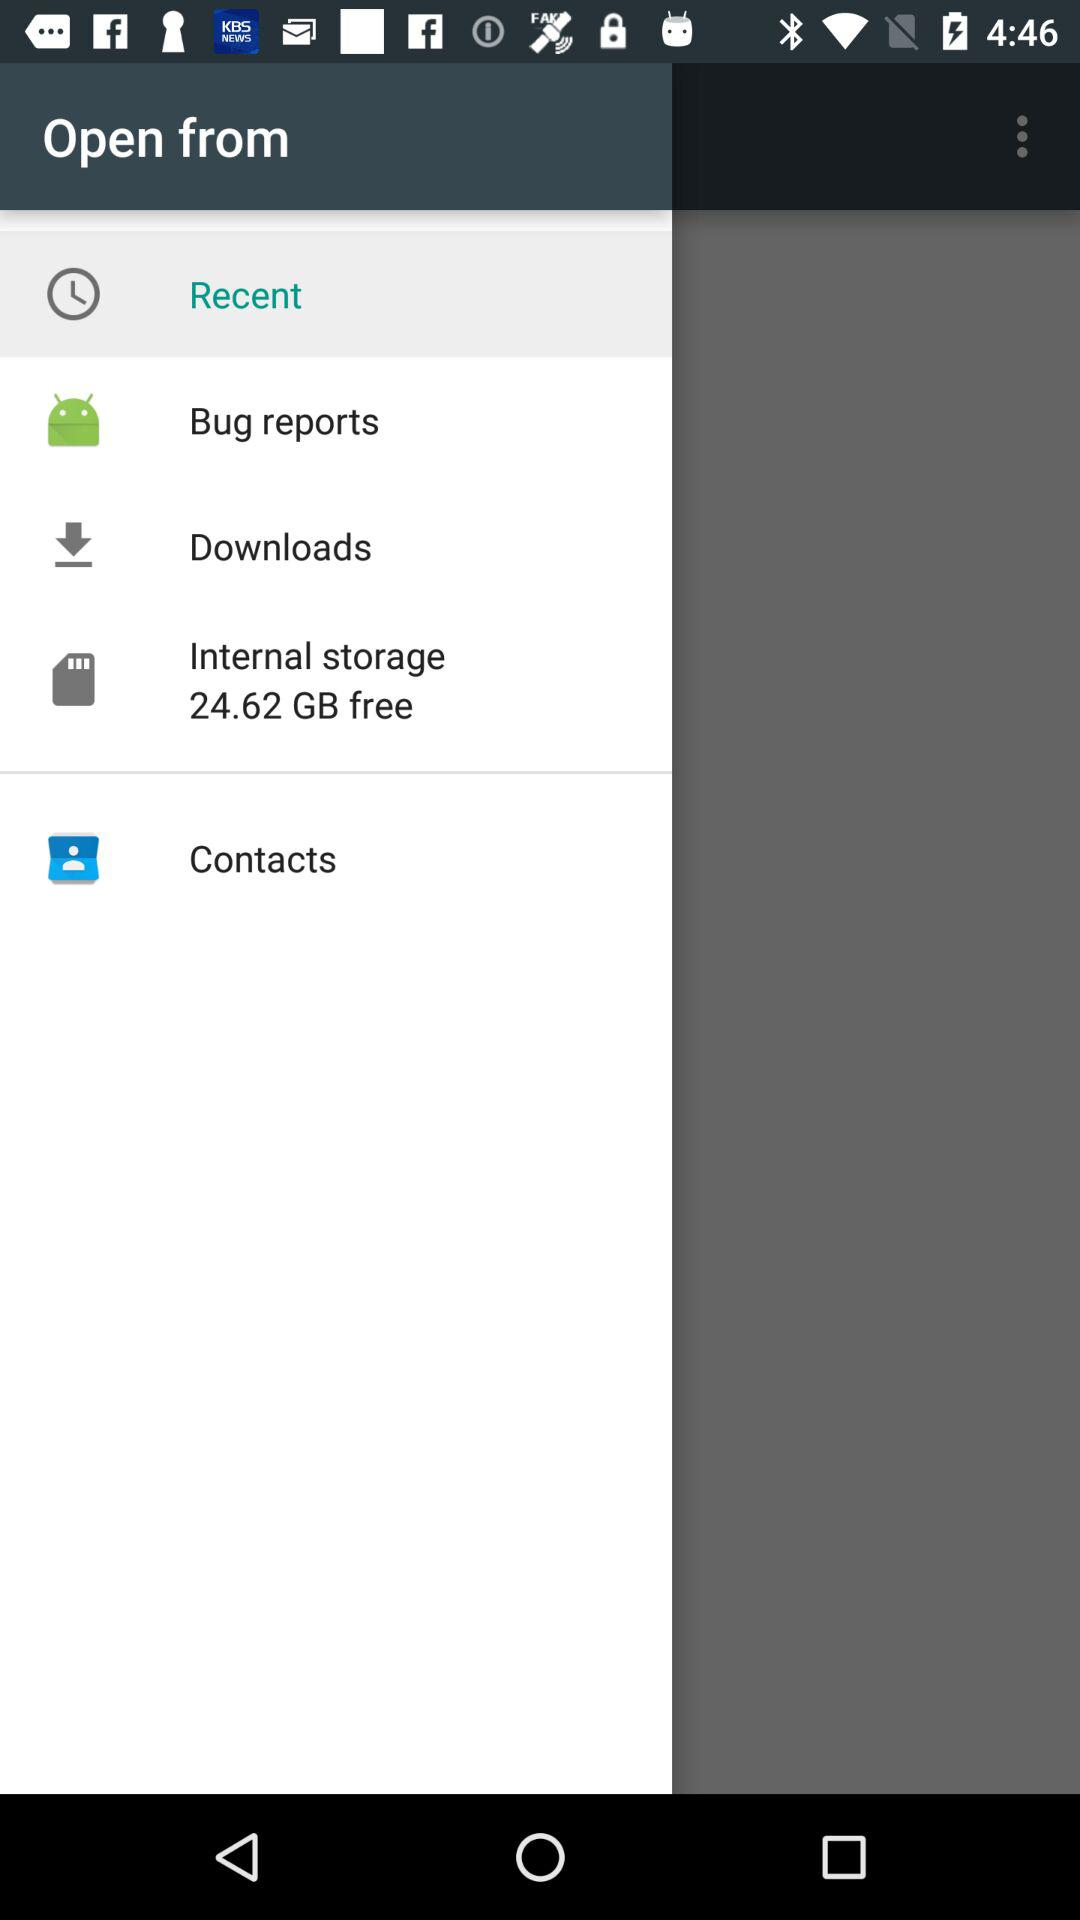How much internal storage is available? The available internal storage is 24.62 GB. 